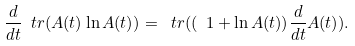<formula> <loc_0><loc_0><loc_500><loc_500>\frac { d } { d t } \ t r ( A ( t ) \ln A ( t ) ) = \ t r ( ( \ 1 + \ln A ( t ) ) \frac { d } { d t } A ( t ) ) .</formula> 